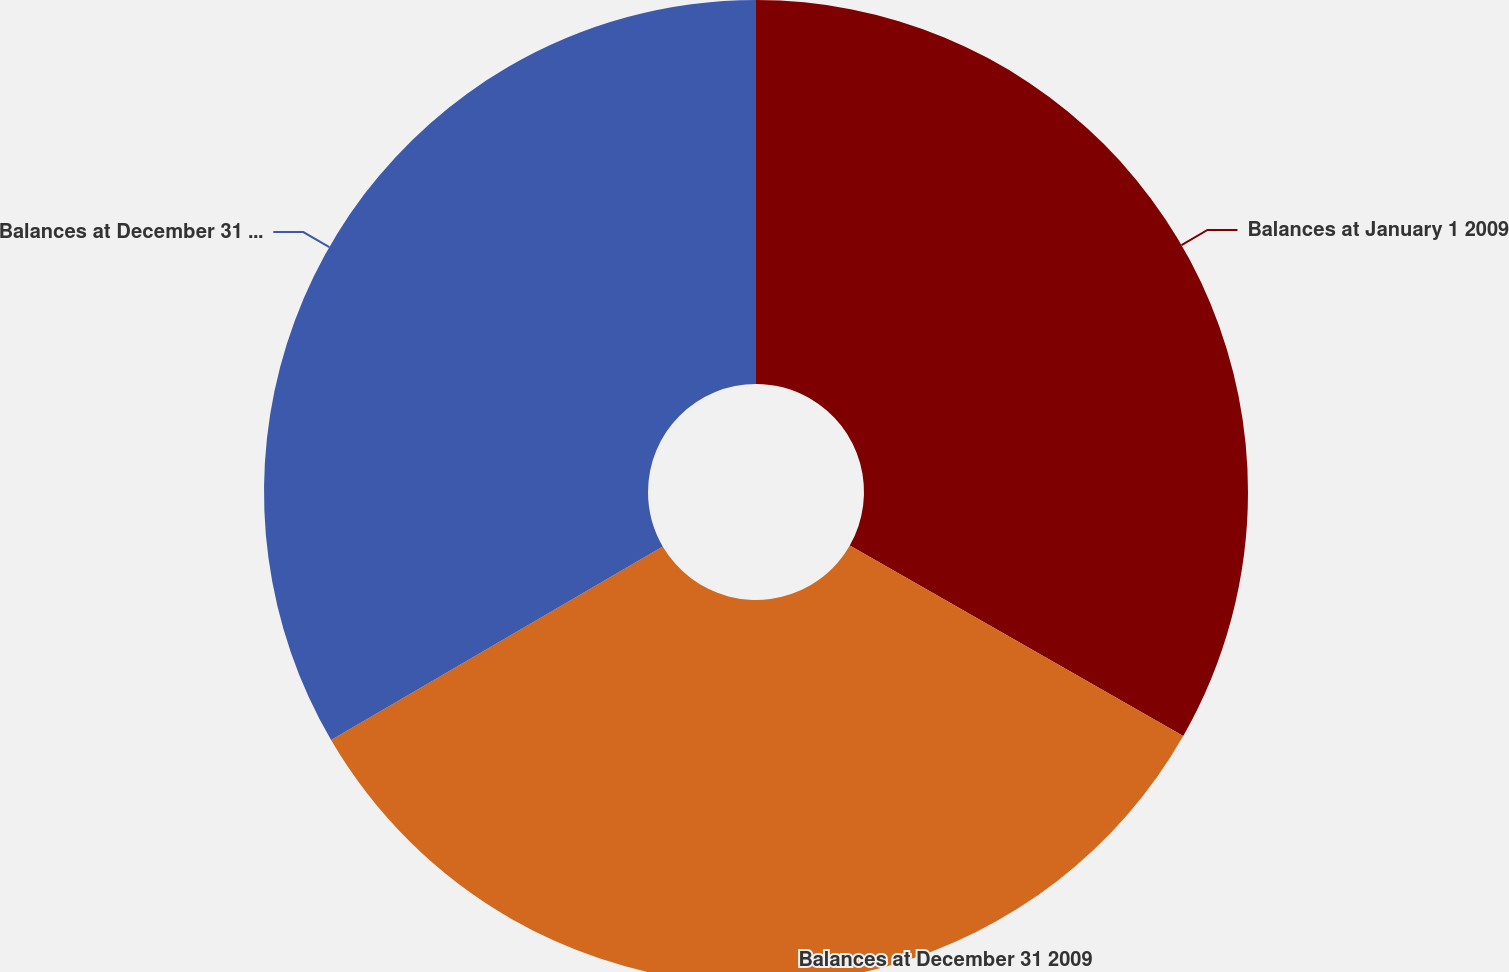Convert chart. <chart><loc_0><loc_0><loc_500><loc_500><pie_chart><fcel>Balances at January 1 2009<fcel>Balances at December 31 2009<fcel>Balances at December 31 2010<nl><fcel>33.26%<fcel>33.33%<fcel>33.41%<nl></chart> 